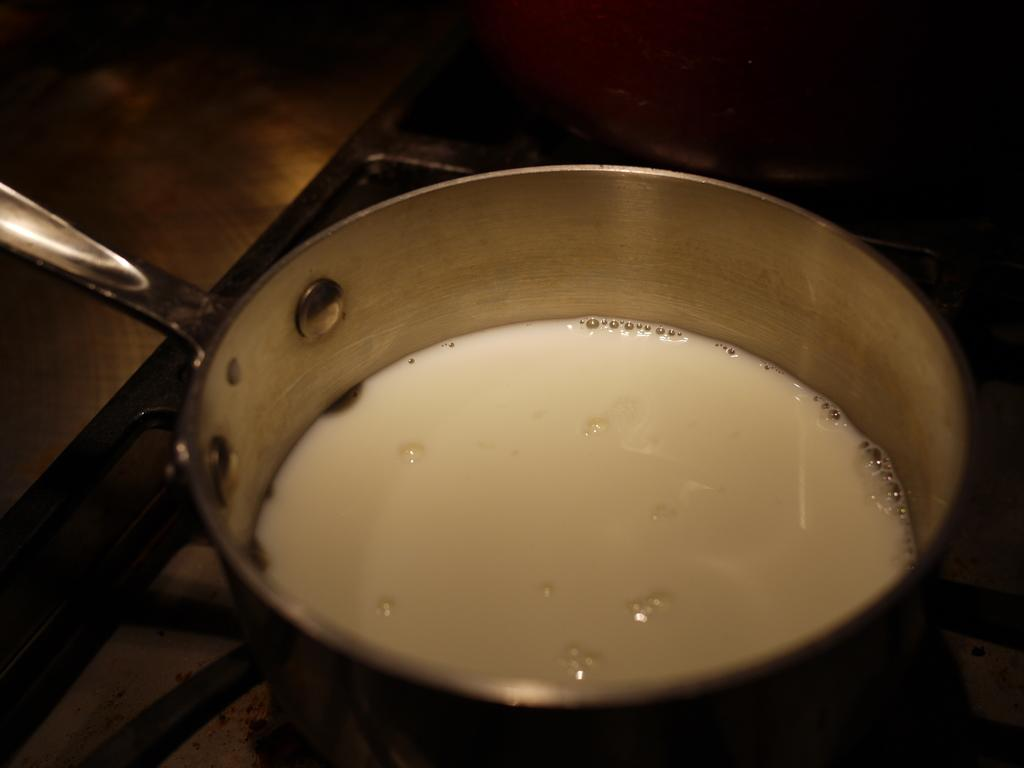What is in the cooking pan that is visible in the image? The cooking pan contains milk in the image. Where is the cooking pan located in the image? The cooking pan is on a grill in the image. What else can be seen on the grill in the image? There is a cooking vessel on the grill in the image. Can you see the boy's wrist in the image? There is no boy or wrist present in the image; it only features a cooking pan, milk, and a grill. 